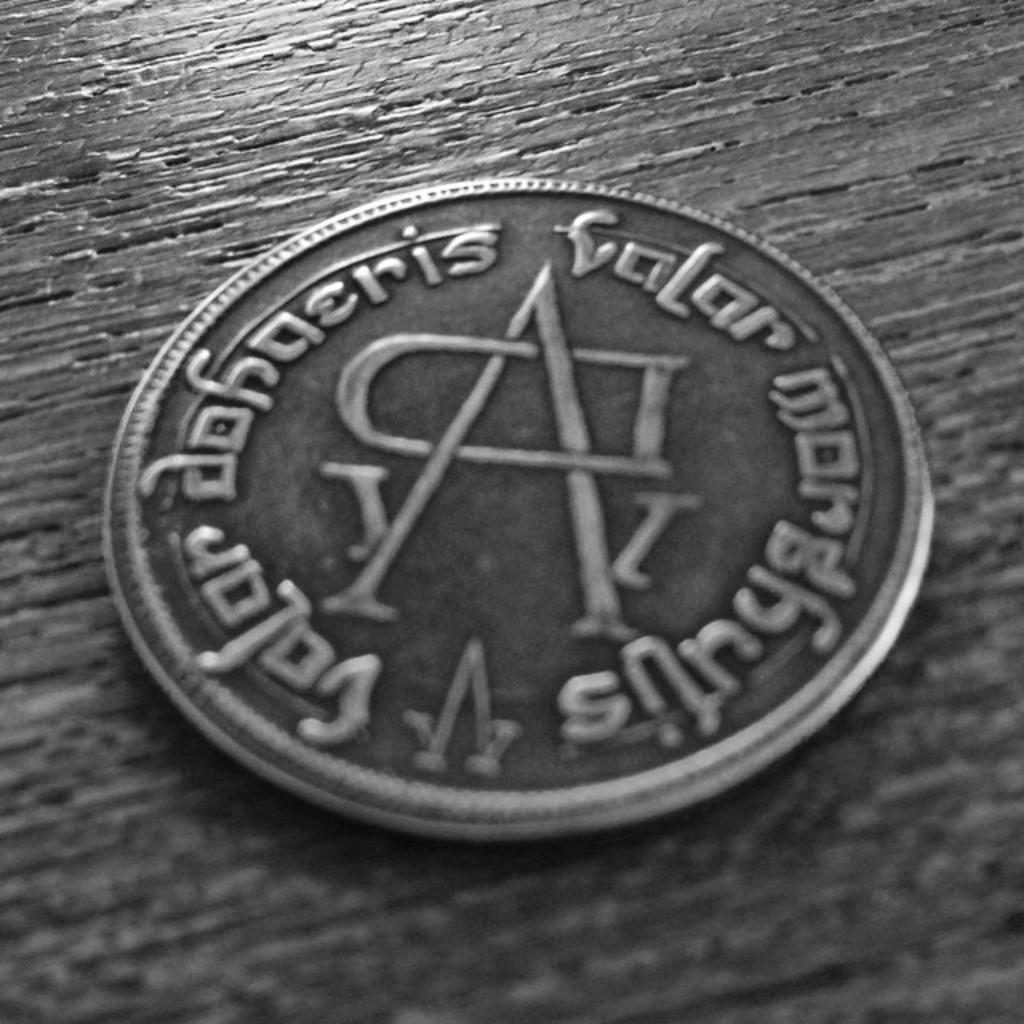<image>
Present a compact description of the photo's key features. A coin sits on a wooden table, the writing on it is foreign, but the letters A and D sit in the middle. 